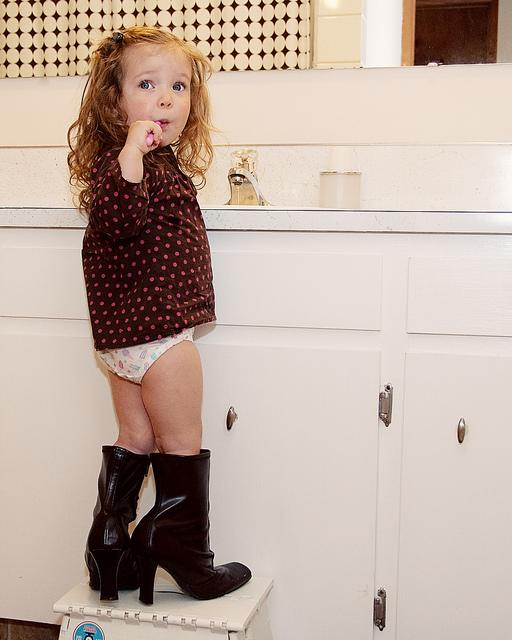Which piece of attire is abnormal for the child to wear?

Choices:
A) boots
B) nothing
C) underwear
D) shirt boots 